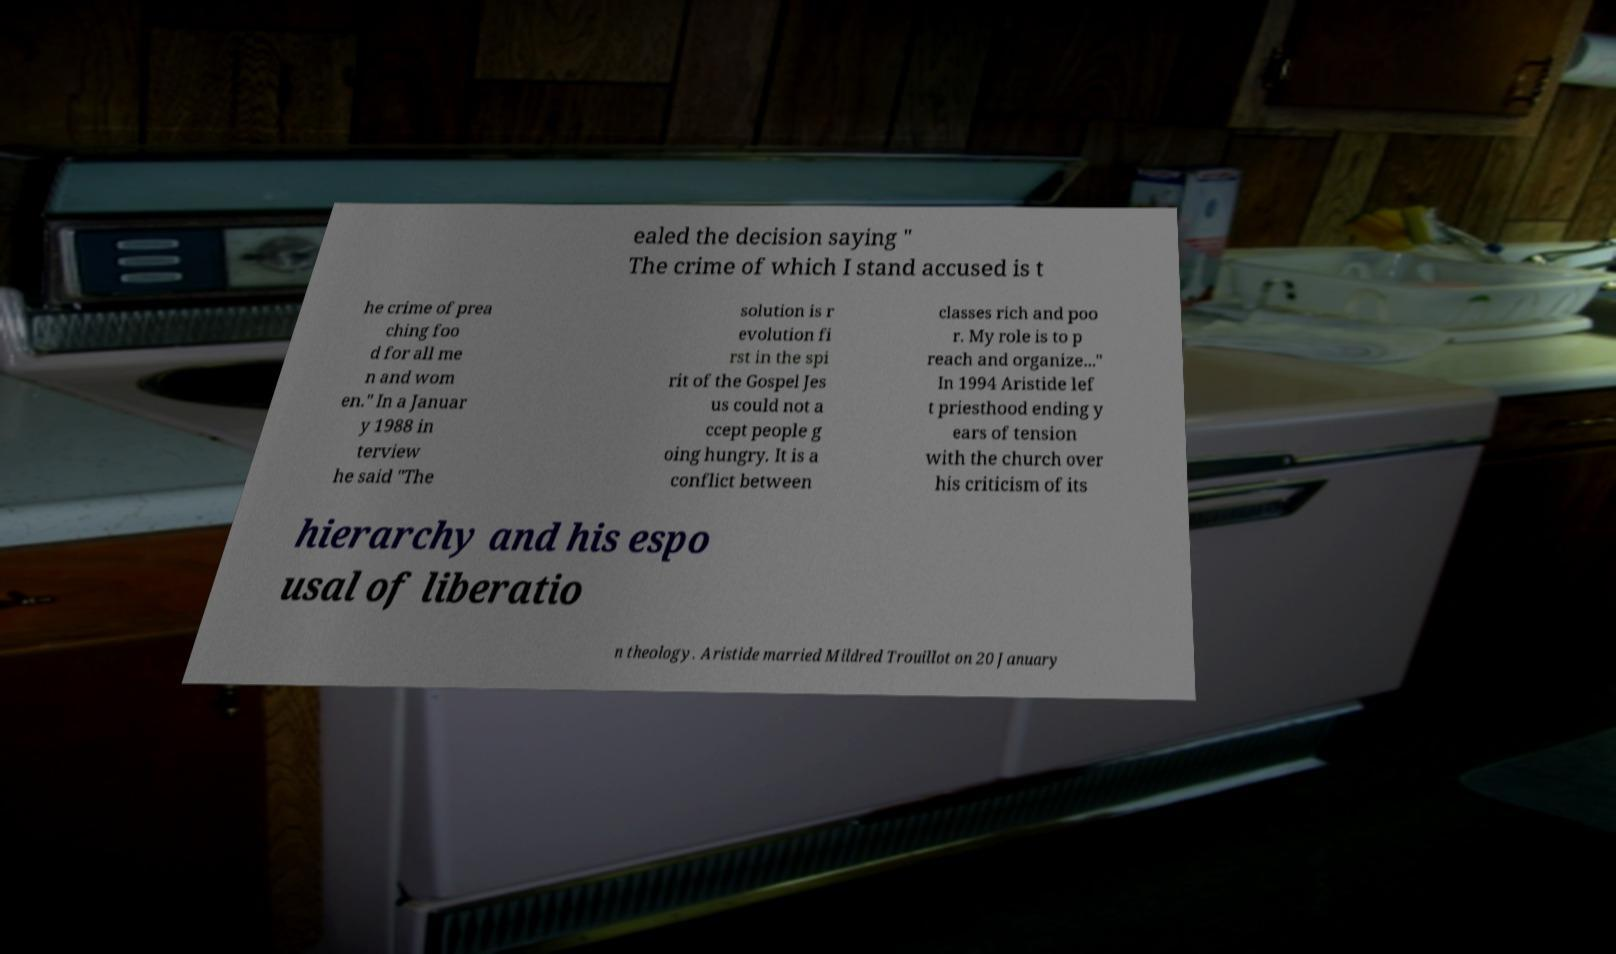Can you accurately transcribe the text from the provided image for me? ealed the decision saying " The crime of which I stand accused is t he crime of prea ching foo d for all me n and wom en." In a Januar y 1988 in terview he said "The solution is r evolution fi rst in the spi rit of the Gospel Jes us could not a ccept people g oing hungry. It is a conflict between classes rich and poo r. My role is to p reach and organize..." In 1994 Aristide lef t priesthood ending y ears of tension with the church over his criticism of its hierarchy and his espo usal of liberatio n theology. Aristide married Mildred Trouillot on 20 January 